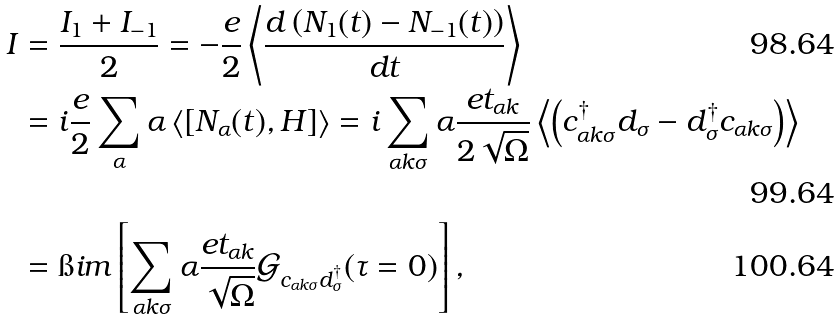<formula> <loc_0><loc_0><loc_500><loc_500>I & = \frac { I _ { 1 } + I _ { - 1 } } { 2 } = - \frac { e } { 2 } \left \langle \frac { d \left ( N _ { 1 } ( t ) - N _ { - 1 } ( t ) \right ) } { d t } \right \rangle \\ & = i \frac { e } { 2 } \sum _ { \alpha } \alpha \left \langle [ N _ { \alpha } ( t ) , H ] \right \rangle = i \sum _ { \alpha k \sigma } \alpha \frac { e t _ { \alpha k } } { 2 \sqrt { \Omega } } \left \langle \left ( c ^ { \dag } _ { \alpha k \sigma } d _ { \sigma } - d ^ { \dag } _ { \sigma } c _ { \alpha k \sigma } \right ) \right \rangle \\ & = \i i m \left [ \sum _ { \alpha k \sigma } \alpha \frac { e t _ { \alpha k } } { \sqrt { \Omega } } \mathcal { G } _ { c _ { \alpha k \sigma } d _ { \sigma } ^ { \dag } } ( \tau = 0 ) \right ] ,</formula> 